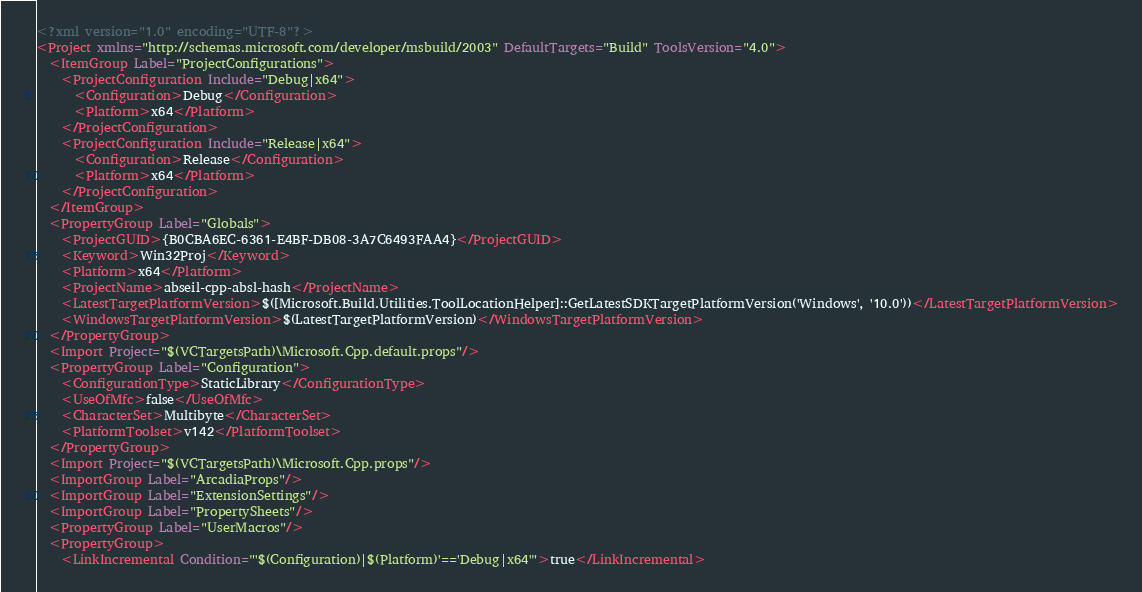<code> <loc_0><loc_0><loc_500><loc_500><_XML_><?xml version="1.0" encoding="UTF-8"?>
<Project xmlns="http://schemas.microsoft.com/developer/msbuild/2003" DefaultTargets="Build" ToolsVersion="4.0">
  <ItemGroup Label="ProjectConfigurations">
    <ProjectConfiguration Include="Debug|x64">
      <Configuration>Debug</Configuration>
      <Platform>x64</Platform>
    </ProjectConfiguration>
    <ProjectConfiguration Include="Release|x64">
      <Configuration>Release</Configuration>
      <Platform>x64</Platform>
    </ProjectConfiguration>
  </ItemGroup>
  <PropertyGroup Label="Globals">
    <ProjectGUID>{B0CBA6EC-6361-E4BF-DB08-3A7C6493FAA4}</ProjectGUID>
    <Keyword>Win32Proj</Keyword>
    <Platform>x64</Platform>
    <ProjectName>abseil-cpp-absl-hash</ProjectName>
    <LatestTargetPlatformVersion>$([Microsoft.Build.Utilities.ToolLocationHelper]::GetLatestSDKTargetPlatformVersion('Windows', '10.0'))</LatestTargetPlatformVersion>
    <WindowsTargetPlatformVersion>$(LatestTargetPlatformVersion)</WindowsTargetPlatformVersion>
  </PropertyGroup>
  <Import Project="$(VCTargetsPath)\Microsoft.Cpp.default.props"/>
  <PropertyGroup Label="Configuration">
    <ConfigurationType>StaticLibrary</ConfigurationType>
    <UseOfMfc>false</UseOfMfc>
    <CharacterSet>Multibyte</CharacterSet>
    <PlatformToolset>v142</PlatformToolset>
  </PropertyGroup>
  <Import Project="$(VCTargetsPath)\Microsoft.Cpp.props"/>
  <ImportGroup Label="ArcadiaProps"/>
  <ImportGroup Label="ExtensionSettings"/>
  <ImportGroup Label="PropertySheets"/>
  <PropertyGroup Label="UserMacros"/>
  <PropertyGroup>
    <LinkIncremental Condition="'$(Configuration)|$(Platform)'=='Debug|x64'">true</LinkIncremental></code> 